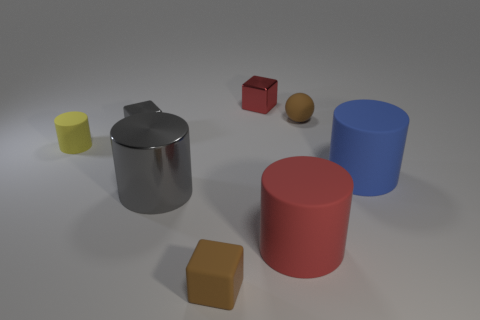How many large objects are blue blocks or cylinders?
Keep it short and to the point. 3. Are there an equal number of yellow matte cylinders in front of the gray cylinder and big red matte things behind the blue cylinder?
Give a very brief answer. Yes. How many other objects are the same color as the large metal cylinder?
Give a very brief answer. 1. Is the number of red rubber cylinders on the left side of the red matte cylinder the same as the number of small brown matte balls?
Ensure brevity in your answer.  No. Does the gray cube have the same size as the brown rubber cube?
Your response must be concise. Yes. There is a tiny block that is in front of the brown sphere and behind the small brown matte block; what material is it made of?
Make the answer very short. Metal. How many big green things have the same shape as the big red thing?
Offer a very short reply. 0. What is the material of the tiny brown object that is behind the tiny yellow matte object?
Offer a terse response. Rubber. Is the number of small balls on the left side of the small red thing less than the number of brown metallic balls?
Offer a terse response. No. Is the shape of the red metallic object the same as the blue thing?
Provide a succinct answer. No. 